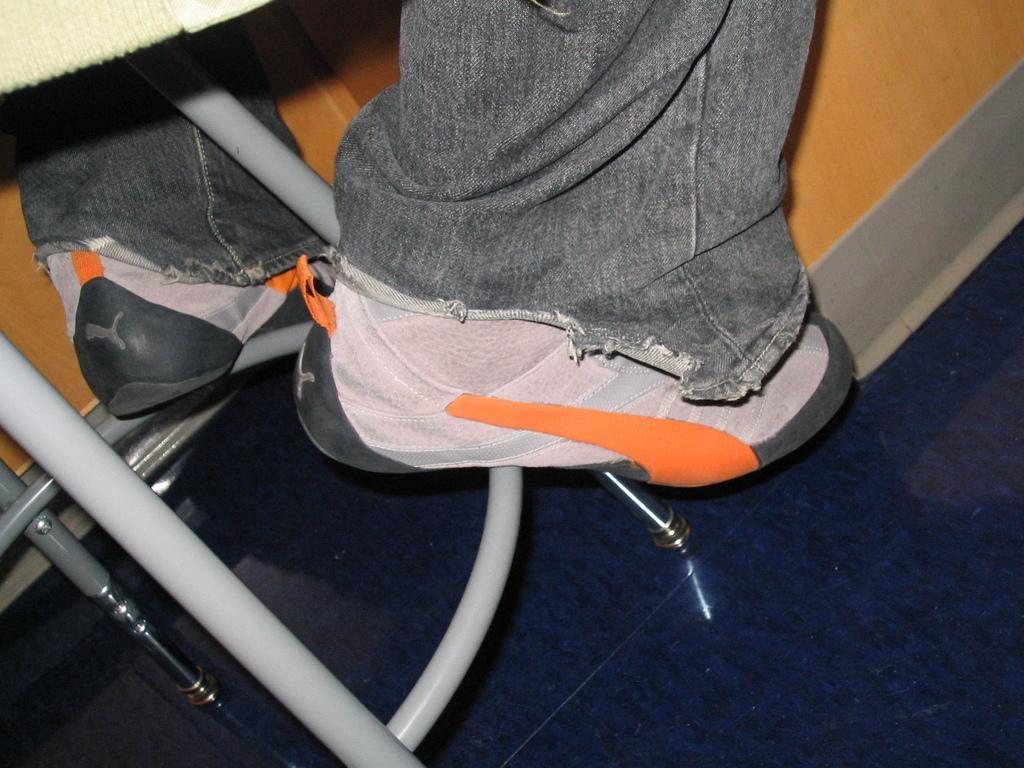Please provide a concise description of this image. In this picture we can see the floor, rods, shoes, cloth and in the background we can see a wooden object. 